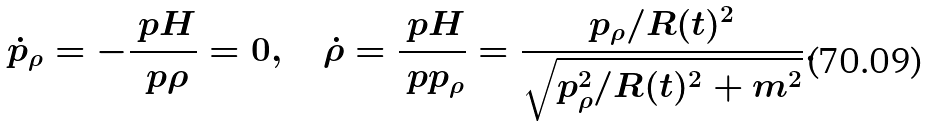<formula> <loc_0><loc_0><loc_500><loc_500>\dot { p } _ { \rho } = - \frac { \ p H } { \ p \rho } = 0 , \quad \dot { \rho } = \frac { \ p H } { \ p p _ { \rho } } = \frac { p _ { \rho } / R ( t ) ^ { 2 } } { \sqrt { p _ { \rho } ^ { 2 } / R ( t ) ^ { 2 } + m ^ { 2 } } } .</formula> 